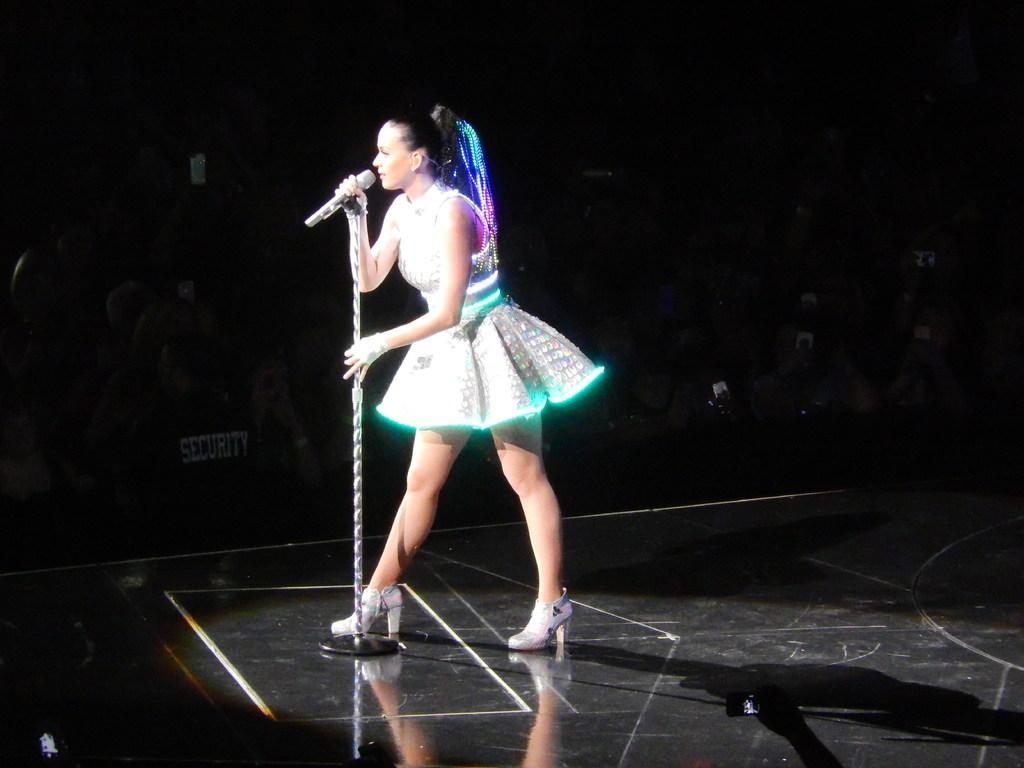How would you summarize this image in a sentence or two? In this picture I can see the platform in front, on which I see a woman who is holding the mic and the tripod and I see that she is wearing white dress and I see the lights. In the background I see few people and I see that it is dark. 